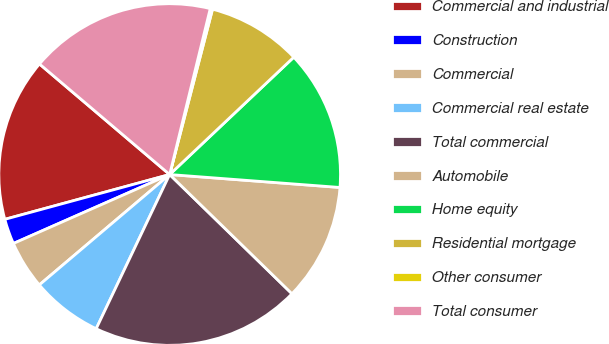<chart> <loc_0><loc_0><loc_500><loc_500><pie_chart><fcel>Commercial and industrial<fcel>Construction<fcel>Commercial<fcel>Commercial real estate<fcel>Total commercial<fcel>Automobile<fcel>Home equity<fcel>Residential mortgage<fcel>Other consumer<fcel>Total consumer<nl><fcel>15.43%<fcel>2.39%<fcel>4.57%<fcel>6.74%<fcel>19.78%<fcel>11.09%<fcel>13.26%<fcel>8.91%<fcel>0.22%<fcel>17.61%<nl></chart> 